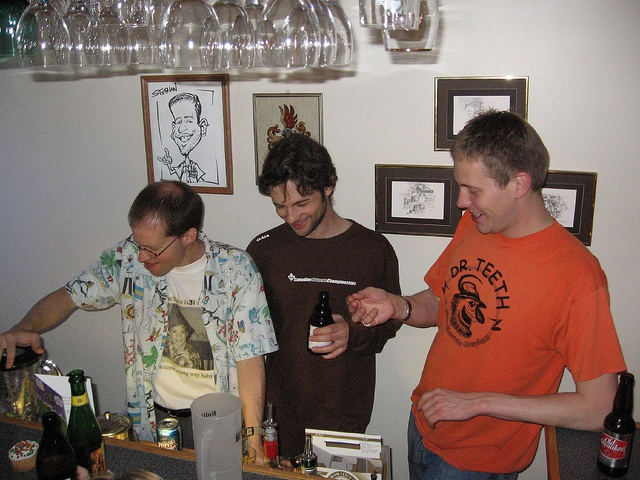Describe the objects in this image and their specific colors. I can see people in black and brown tones, people in black, darkgray, gray, and maroon tones, people in black, brown, and maroon tones, bottle in black, gray, and maroon tones, and cup in black and gray tones in this image. 